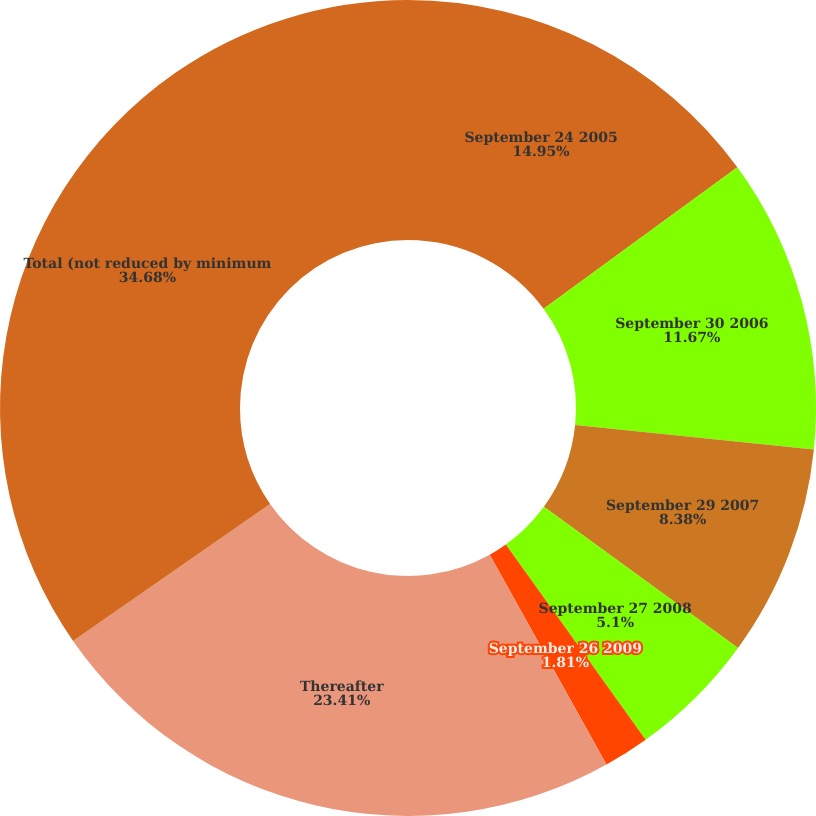<chart> <loc_0><loc_0><loc_500><loc_500><pie_chart><fcel>September 24 2005<fcel>September 30 2006<fcel>September 29 2007<fcel>September 27 2008<fcel>September 26 2009<fcel>Thereafter<fcel>Total (not reduced by minimum<nl><fcel>14.95%<fcel>11.67%<fcel>8.38%<fcel>5.1%<fcel>1.81%<fcel>23.41%<fcel>34.67%<nl></chart> 